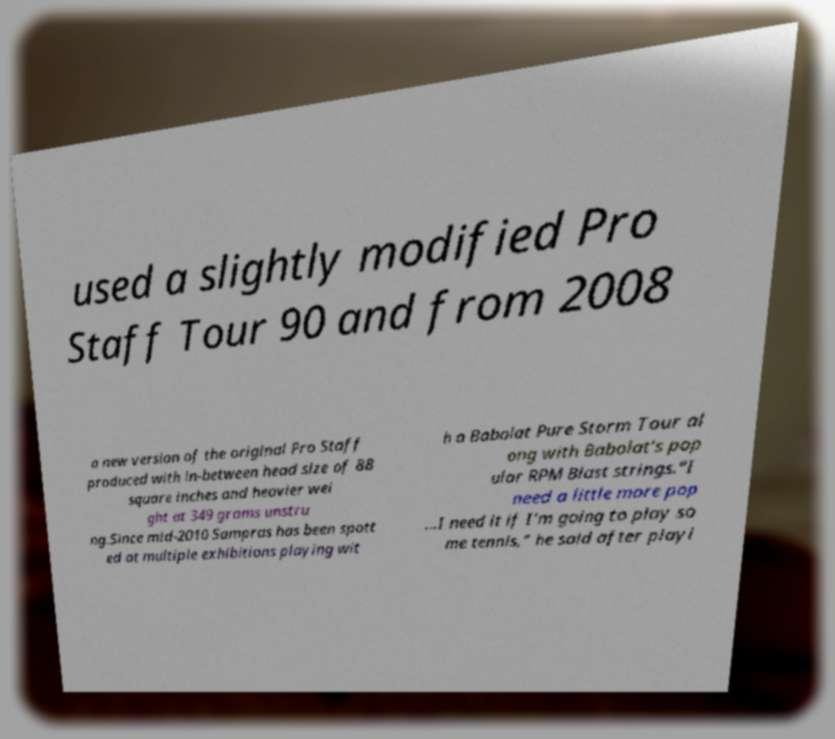Please identify and transcribe the text found in this image. used a slightly modified Pro Staff Tour 90 and from 2008 a new version of the original Pro Staff produced with in-between head size of 88 square inches and heavier wei ght at 349 grams unstru ng.Since mid-2010 Sampras has been spott ed at multiple exhibitions playing wit h a Babolat Pure Storm Tour al ong with Babolat's pop ular RPM Blast strings."I need a little more pop ...I need it if I'm going to play so me tennis," he said after playi 